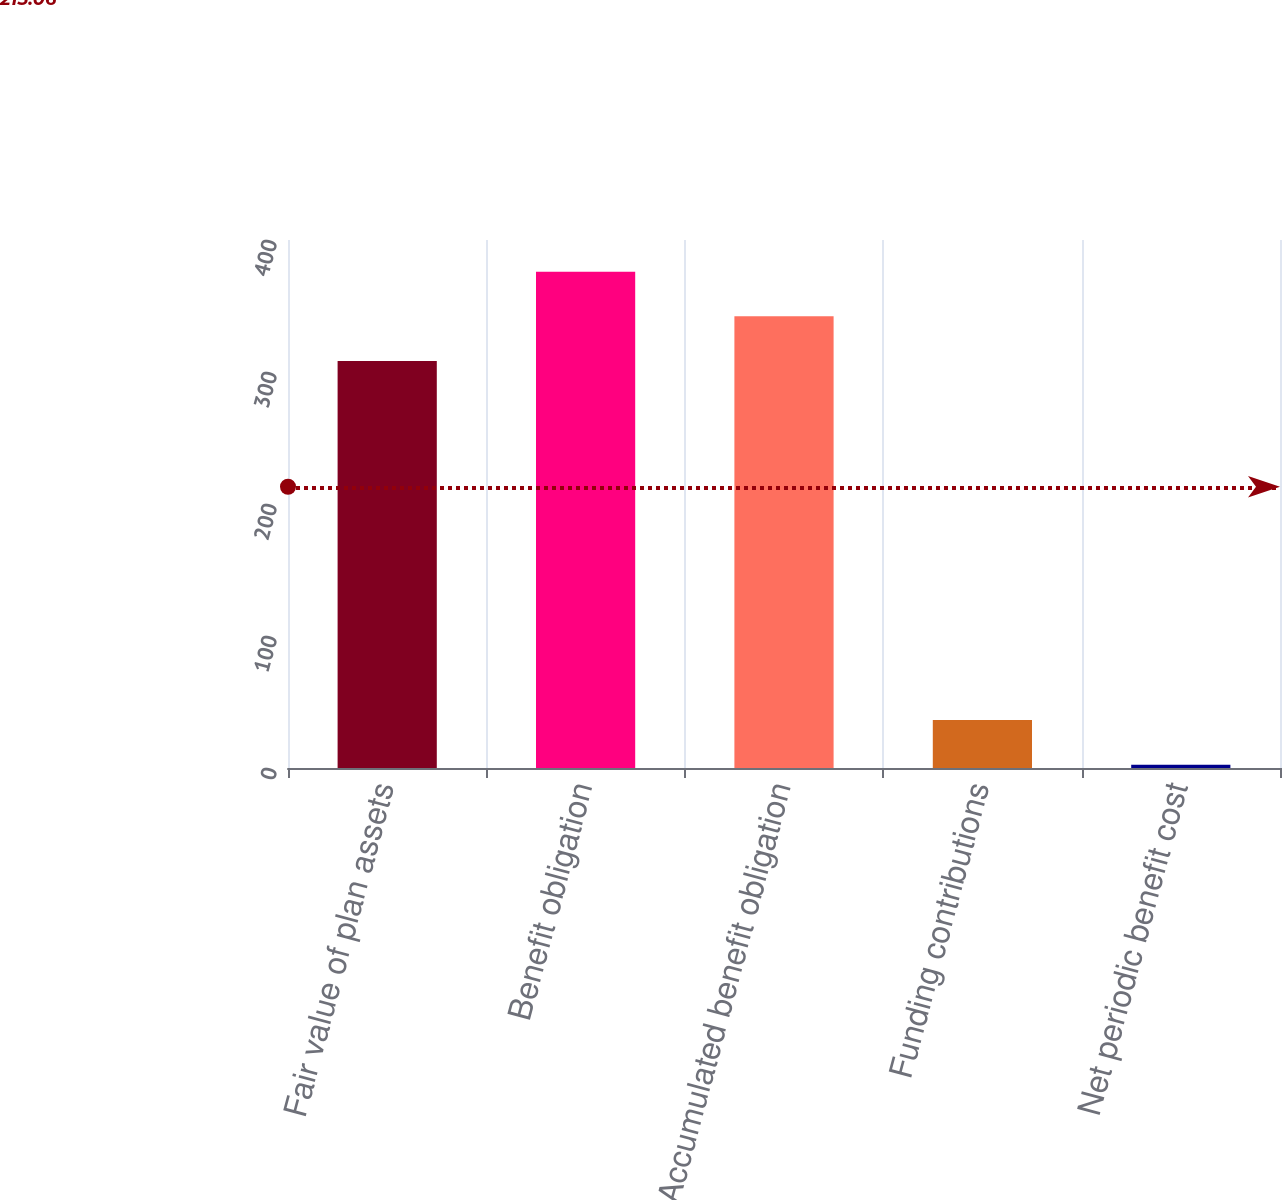Convert chart. <chart><loc_0><loc_0><loc_500><loc_500><bar_chart><fcel>Fair value of plan assets<fcel>Benefit obligation<fcel>Accumulated benefit obligation<fcel>Funding contributions<fcel>Net periodic benefit cost<nl><fcel>308.4<fcel>375.94<fcel>342.17<fcel>36.27<fcel>2.5<nl></chart> 